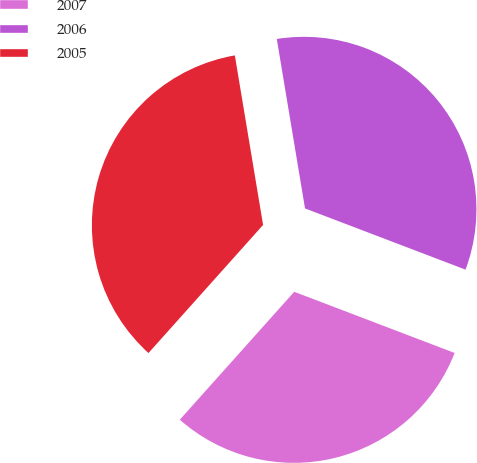Convert chart to OTSL. <chart><loc_0><loc_0><loc_500><loc_500><pie_chart><fcel>2007<fcel>2006<fcel>2005<nl><fcel>30.82%<fcel>33.43%<fcel>35.76%<nl></chart> 